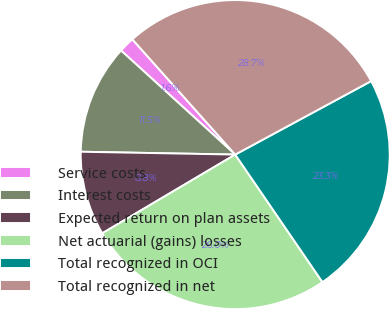Convert chart to OTSL. <chart><loc_0><loc_0><loc_500><loc_500><pie_chart><fcel>Service costs<fcel>Interest costs<fcel>Expected return on plan assets<fcel>Net actuarial (gains) losses<fcel>Total recognized in OCI<fcel>Total recognized in net<nl><fcel>1.64%<fcel>11.47%<fcel>8.8%<fcel>26.04%<fcel>23.34%<fcel>28.71%<nl></chart> 